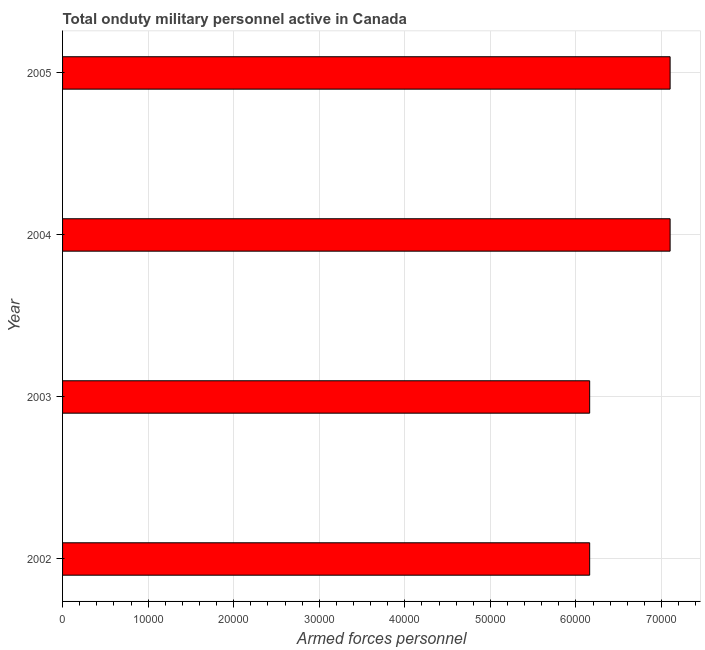Does the graph contain grids?
Your answer should be very brief. Yes. What is the title of the graph?
Provide a succinct answer. Total onduty military personnel active in Canada. What is the label or title of the X-axis?
Your answer should be very brief. Armed forces personnel. What is the label or title of the Y-axis?
Give a very brief answer. Year. What is the number of armed forces personnel in 2002?
Your response must be concise. 6.16e+04. Across all years, what is the maximum number of armed forces personnel?
Offer a very short reply. 7.10e+04. Across all years, what is the minimum number of armed forces personnel?
Offer a very short reply. 6.16e+04. What is the sum of the number of armed forces personnel?
Ensure brevity in your answer.  2.65e+05. What is the difference between the number of armed forces personnel in 2003 and 2004?
Your answer should be compact. -9400. What is the average number of armed forces personnel per year?
Offer a terse response. 6.63e+04. What is the median number of armed forces personnel?
Your answer should be very brief. 6.63e+04. In how many years, is the number of armed forces personnel greater than 42000 ?
Offer a very short reply. 4. What is the ratio of the number of armed forces personnel in 2002 to that in 2005?
Ensure brevity in your answer.  0.87. Is the number of armed forces personnel in 2003 less than that in 2005?
Make the answer very short. Yes. Is the sum of the number of armed forces personnel in 2002 and 2005 greater than the maximum number of armed forces personnel across all years?
Provide a succinct answer. Yes. What is the difference between the highest and the lowest number of armed forces personnel?
Your answer should be very brief. 9400. What is the difference between two consecutive major ticks on the X-axis?
Make the answer very short. 10000. Are the values on the major ticks of X-axis written in scientific E-notation?
Keep it short and to the point. No. What is the Armed forces personnel in 2002?
Offer a terse response. 6.16e+04. What is the Armed forces personnel of 2003?
Your answer should be compact. 6.16e+04. What is the Armed forces personnel of 2004?
Offer a terse response. 7.10e+04. What is the Armed forces personnel of 2005?
Provide a short and direct response. 7.10e+04. What is the difference between the Armed forces personnel in 2002 and 2004?
Offer a terse response. -9400. What is the difference between the Armed forces personnel in 2002 and 2005?
Your answer should be very brief. -9400. What is the difference between the Armed forces personnel in 2003 and 2004?
Make the answer very short. -9400. What is the difference between the Armed forces personnel in 2003 and 2005?
Offer a terse response. -9400. What is the ratio of the Armed forces personnel in 2002 to that in 2003?
Your answer should be compact. 1. What is the ratio of the Armed forces personnel in 2002 to that in 2004?
Make the answer very short. 0.87. What is the ratio of the Armed forces personnel in 2002 to that in 2005?
Ensure brevity in your answer.  0.87. What is the ratio of the Armed forces personnel in 2003 to that in 2004?
Your answer should be compact. 0.87. What is the ratio of the Armed forces personnel in 2003 to that in 2005?
Provide a succinct answer. 0.87. 